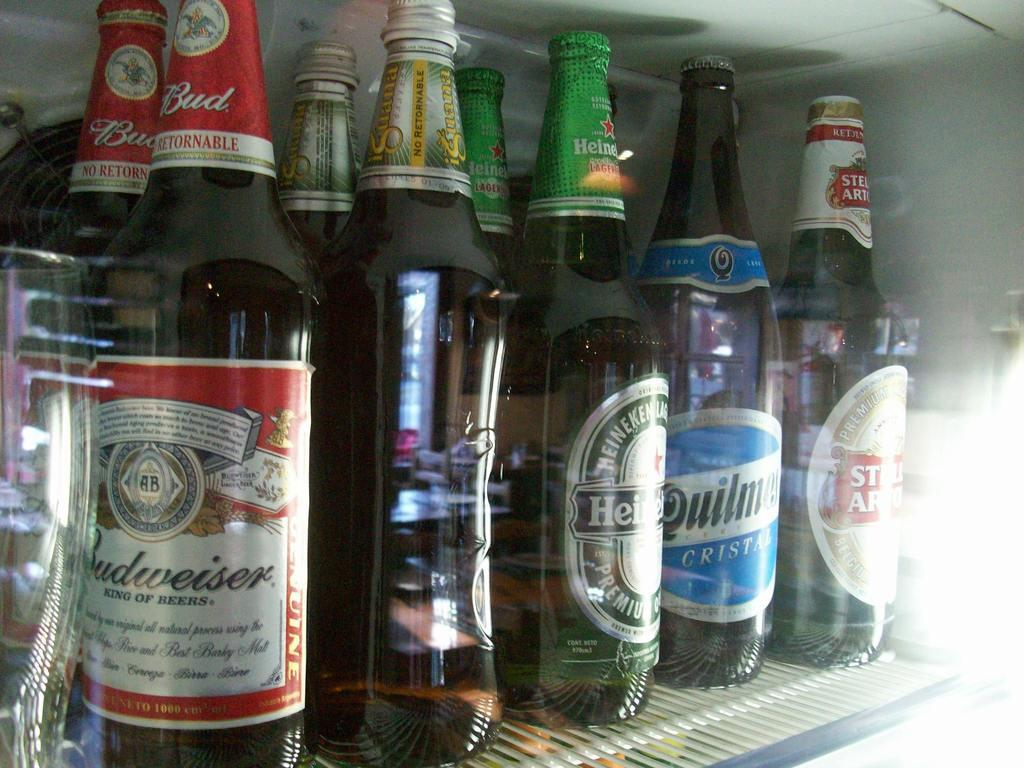<image>
Create a compact narrative representing the image presented. A refrigerator contains many types of beer, including Budweiser. 